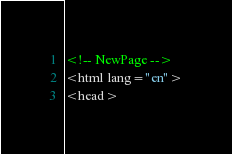<code> <loc_0><loc_0><loc_500><loc_500><_HTML_><!-- NewPage -->
<html lang="en">
<head></code> 